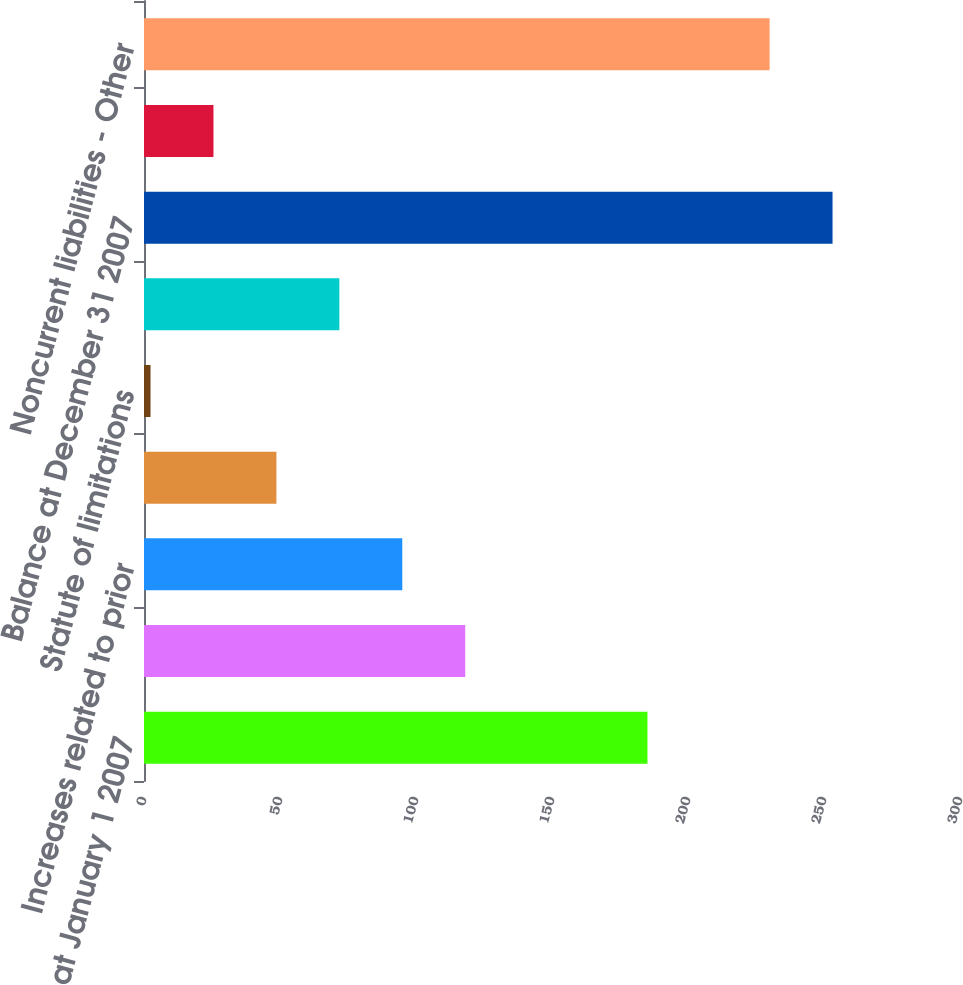Convert chart. <chart><loc_0><loc_0><loc_500><loc_500><bar_chart><fcel>Balance at January 1 2007<fcel>Increases related to current<fcel>Increases related to prior<fcel>Settlements and resolutions of<fcel>Statute of limitations<fcel>Other<fcel>Balance at December 31 2007<fcel>Current liabilities - Income<fcel>Noncurrent liabilities - Other<nl><fcel>185.1<fcel>118.1<fcel>94.96<fcel>48.68<fcel>2.4<fcel>71.82<fcel>253.14<fcel>25.54<fcel>230<nl></chart> 